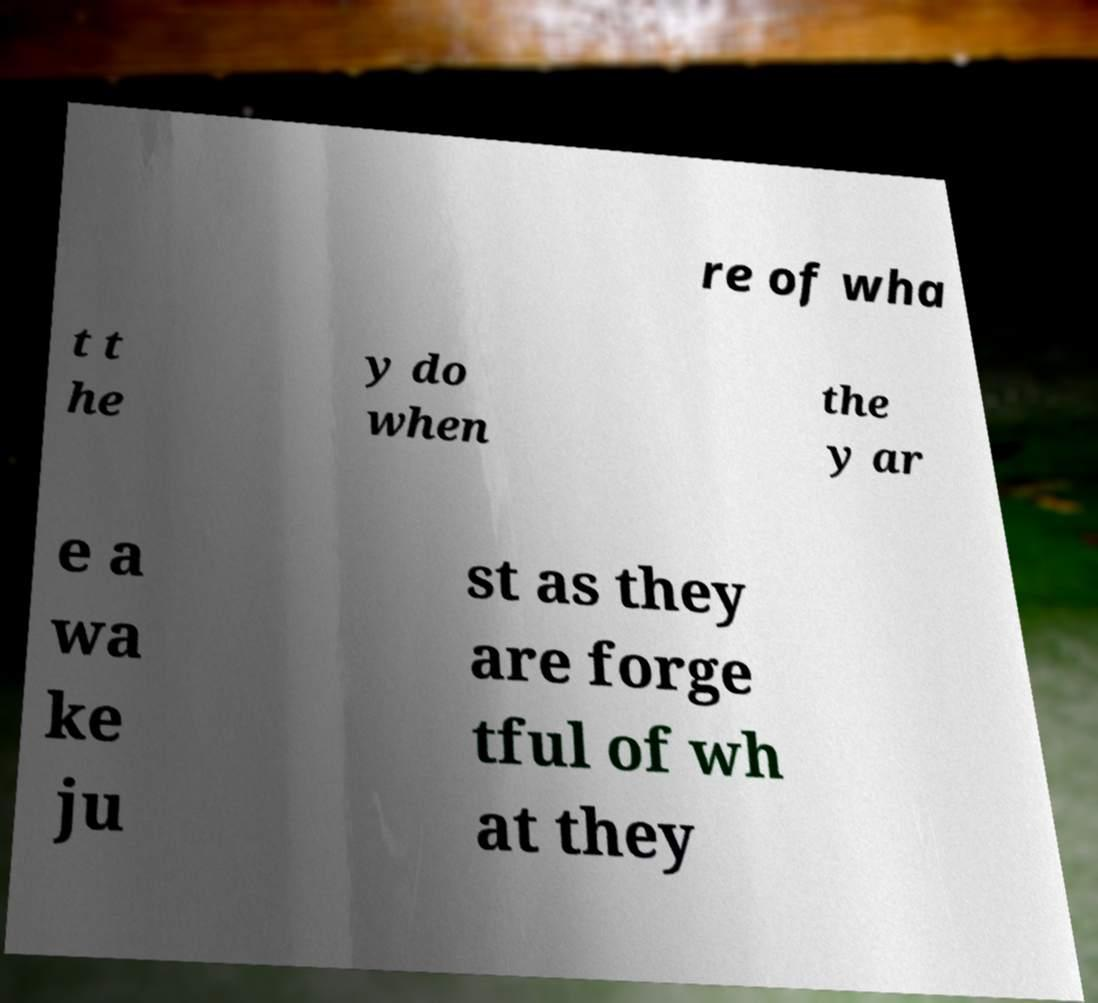Could you assist in decoding the text presented in this image and type it out clearly? re of wha t t he y do when the y ar e a wa ke ju st as they are forge tful of wh at they 